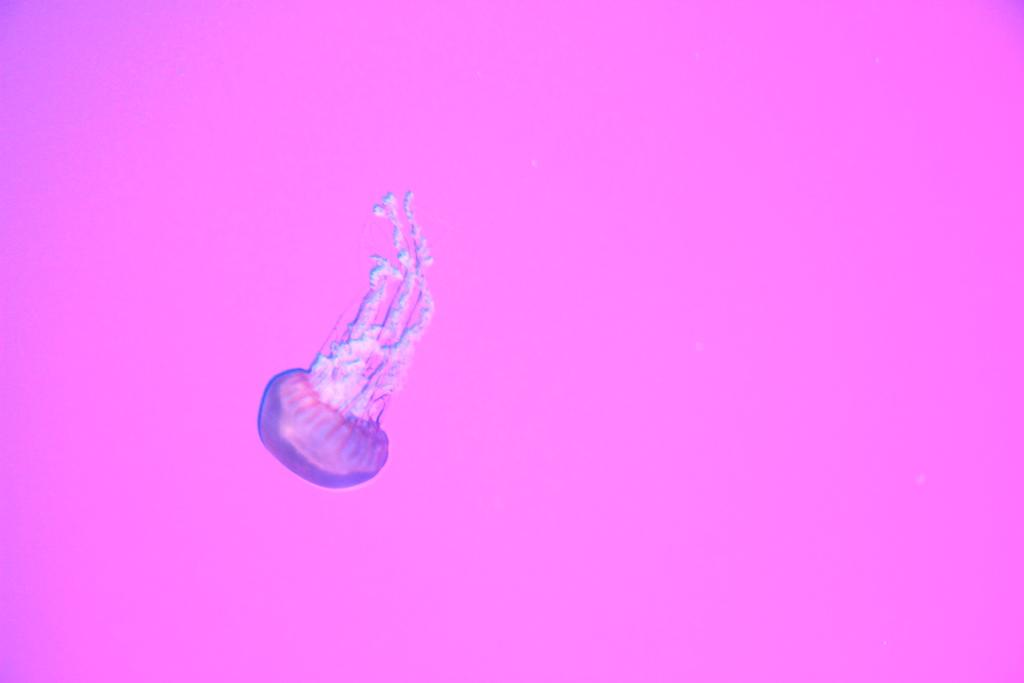What type of animal is in the image? There is a jellyfish in the image. What is the weight of the metal maid in the image? There is no metal maid present in the image, and therefore no weight can be determined. 